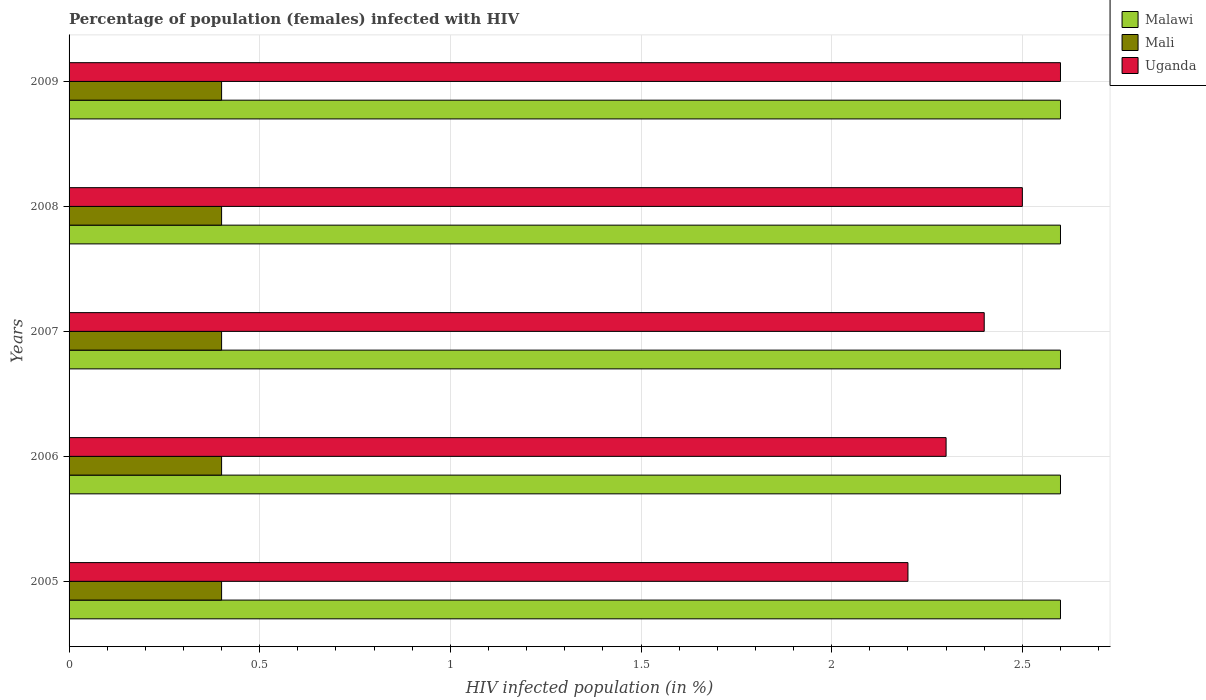How many groups of bars are there?
Keep it short and to the point. 5. In how many cases, is the number of bars for a given year not equal to the number of legend labels?
Offer a terse response. 0. What is the percentage of HIV infected female population in Mali in 2007?
Give a very brief answer. 0.4. Across all years, what is the maximum percentage of HIV infected female population in Uganda?
Your answer should be very brief. 2.6. In which year was the percentage of HIV infected female population in Mali maximum?
Your response must be concise. 2005. What is the total percentage of HIV infected female population in Mali in the graph?
Provide a short and direct response. 2. What is the difference between the percentage of HIV infected female population in Mali in 2007 and that in 2009?
Offer a terse response. 0. What is the difference between the percentage of HIV infected female population in Uganda in 2006 and the percentage of HIV infected female population in Malawi in 2009?
Provide a succinct answer. -0.3. In the year 2005, what is the difference between the percentage of HIV infected female population in Malawi and percentage of HIV infected female population in Uganda?
Your response must be concise. 0.4. Is the percentage of HIV infected female population in Malawi in 2006 less than that in 2007?
Make the answer very short. No. Is the difference between the percentage of HIV infected female population in Malawi in 2005 and 2009 greater than the difference between the percentage of HIV infected female population in Uganda in 2005 and 2009?
Make the answer very short. Yes. What is the difference between the highest and the lowest percentage of HIV infected female population in Malawi?
Your response must be concise. 0. Is the sum of the percentage of HIV infected female population in Malawi in 2005 and 2008 greater than the maximum percentage of HIV infected female population in Uganda across all years?
Ensure brevity in your answer.  Yes. What does the 3rd bar from the top in 2009 represents?
Provide a succinct answer. Malawi. What does the 2nd bar from the bottom in 2006 represents?
Ensure brevity in your answer.  Mali. Is it the case that in every year, the sum of the percentage of HIV infected female population in Mali and percentage of HIV infected female population in Uganda is greater than the percentage of HIV infected female population in Malawi?
Keep it short and to the point. No. How many bars are there?
Offer a terse response. 15. Are all the bars in the graph horizontal?
Give a very brief answer. Yes. How many years are there in the graph?
Your answer should be very brief. 5. Are the values on the major ticks of X-axis written in scientific E-notation?
Give a very brief answer. No. Does the graph contain any zero values?
Ensure brevity in your answer.  No. Does the graph contain grids?
Your answer should be compact. Yes. Where does the legend appear in the graph?
Ensure brevity in your answer.  Top right. How are the legend labels stacked?
Your response must be concise. Vertical. What is the title of the graph?
Offer a very short reply. Percentage of population (females) infected with HIV. What is the label or title of the X-axis?
Give a very brief answer. HIV infected population (in %). What is the HIV infected population (in %) in Mali in 2005?
Offer a terse response. 0.4. What is the HIV infected population (in %) in Uganda in 2005?
Your answer should be compact. 2.2. What is the HIV infected population (in %) in Malawi in 2006?
Offer a very short reply. 2.6. What is the HIV infected population (in %) of Mali in 2006?
Your response must be concise. 0.4. What is the HIV infected population (in %) of Malawi in 2007?
Your answer should be compact. 2.6. What is the HIV infected population (in %) of Mali in 2007?
Your answer should be compact. 0.4. What is the HIV infected population (in %) of Malawi in 2008?
Make the answer very short. 2.6. What is the HIV infected population (in %) of Mali in 2008?
Ensure brevity in your answer.  0.4. What is the HIV infected population (in %) in Mali in 2009?
Keep it short and to the point. 0.4. Across all years, what is the maximum HIV infected population (in %) in Uganda?
Your response must be concise. 2.6. What is the total HIV infected population (in %) in Malawi in the graph?
Provide a short and direct response. 13. What is the total HIV infected population (in %) in Mali in the graph?
Offer a terse response. 2. What is the difference between the HIV infected population (in %) of Malawi in 2005 and that in 2006?
Provide a succinct answer. 0. What is the difference between the HIV infected population (in %) in Mali in 2005 and that in 2006?
Your answer should be very brief. 0. What is the difference between the HIV infected population (in %) of Malawi in 2005 and that in 2007?
Ensure brevity in your answer.  0. What is the difference between the HIV infected population (in %) in Mali in 2005 and that in 2008?
Make the answer very short. 0. What is the difference between the HIV infected population (in %) of Uganda in 2005 and that in 2008?
Your answer should be compact. -0.3. What is the difference between the HIV infected population (in %) in Uganda in 2005 and that in 2009?
Provide a short and direct response. -0.4. What is the difference between the HIV infected population (in %) of Uganda in 2006 and that in 2007?
Provide a short and direct response. -0.1. What is the difference between the HIV infected population (in %) of Mali in 2006 and that in 2008?
Your response must be concise. 0. What is the difference between the HIV infected population (in %) in Uganda in 2006 and that in 2008?
Offer a very short reply. -0.2. What is the difference between the HIV infected population (in %) of Malawi in 2006 and that in 2009?
Ensure brevity in your answer.  0. What is the difference between the HIV infected population (in %) in Mali in 2006 and that in 2009?
Offer a terse response. 0. What is the difference between the HIV infected population (in %) of Mali in 2007 and that in 2008?
Your answer should be compact. 0. What is the difference between the HIV infected population (in %) in Malawi in 2007 and that in 2009?
Your response must be concise. 0. What is the difference between the HIV infected population (in %) in Mali in 2007 and that in 2009?
Provide a succinct answer. 0. What is the difference between the HIV infected population (in %) of Mali in 2008 and that in 2009?
Offer a terse response. 0. What is the difference between the HIV infected population (in %) of Malawi in 2005 and the HIV infected population (in %) of Mali in 2006?
Offer a very short reply. 2.2. What is the difference between the HIV infected population (in %) in Malawi in 2005 and the HIV infected population (in %) in Uganda in 2006?
Provide a short and direct response. 0.3. What is the difference between the HIV infected population (in %) in Mali in 2005 and the HIV infected population (in %) in Uganda in 2006?
Keep it short and to the point. -1.9. What is the difference between the HIV infected population (in %) in Malawi in 2005 and the HIV infected population (in %) in Uganda in 2007?
Your answer should be compact. 0.2. What is the difference between the HIV infected population (in %) in Malawi in 2005 and the HIV infected population (in %) in Mali in 2008?
Your answer should be compact. 2.2. What is the difference between the HIV infected population (in %) of Malawi in 2005 and the HIV infected population (in %) of Mali in 2009?
Your response must be concise. 2.2. What is the difference between the HIV infected population (in %) in Malawi in 2006 and the HIV infected population (in %) in Mali in 2007?
Offer a terse response. 2.2. What is the difference between the HIV infected population (in %) in Malawi in 2006 and the HIV infected population (in %) in Uganda in 2007?
Provide a succinct answer. 0.2. What is the difference between the HIV infected population (in %) in Mali in 2006 and the HIV infected population (in %) in Uganda in 2007?
Your response must be concise. -2. What is the difference between the HIV infected population (in %) of Malawi in 2006 and the HIV infected population (in %) of Uganda in 2008?
Provide a short and direct response. 0.1. What is the difference between the HIV infected population (in %) in Mali in 2006 and the HIV infected population (in %) in Uganda in 2008?
Provide a succinct answer. -2.1. What is the difference between the HIV infected population (in %) of Malawi in 2006 and the HIV infected population (in %) of Uganda in 2009?
Your answer should be very brief. 0. What is the difference between the HIV infected population (in %) of Mali in 2007 and the HIV infected population (in %) of Uganda in 2008?
Make the answer very short. -2.1. What is the difference between the HIV infected population (in %) of Malawi in 2007 and the HIV infected population (in %) of Mali in 2009?
Your response must be concise. 2.2. What is the difference between the HIV infected population (in %) of Malawi in 2007 and the HIV infected population (in %) of Uganda in 2009?
Your response must be concise. 0. What is the difference between the HIV infected population (in %) of Malawi in 2008 and the HIV infected population (in %) of Mali in 2009?
Ensure brevity in your answer.  2.2. What is the difference between the HIV infected population (in %) of Malawi in 2008 and the HIV infected population (in %) of Uganda in 2009?
Make the answer very short. 0. What is the difference between the HIV infected population (in %) of Mali in 2008 and the HIV infected population (in %) of Uganda in 2009?
Offer a terse response. -2.2. What is the average HIV infected population (in %) in Malawi per year?
Your answer should be very brief. 2.6. What is the average HIV infected population (in %) of Mali per year?
Provide a succinct answer. 0.4. In the year 2005, what is the difference between the HIV infected population (in %) of Malawi and HIV infected population (in %) of Uganda?
Offer a very short reply. 0.4. In the year 2005, what is the difference between the HIV infected population (in %) in Mali and HIV infected population (in %) in Uganda?
Provide a succinct answer. -1.8. In the year 2006, what is the difference between the HIV infected population (in %) of Malawi and HIV infected population (in %) of Uganda?
Provide a short and direct response. 0.3. In the year 2006, what is the difference between the HIV infected population (in %) of Mali and HIV infected population (in %) of Uganda?
Provide a short and direct response. -1.9. In the year 2007, what is the difference between the HIV infected population (in %) of Malawi and HIV infected population (in %) of Uganda?
Your response must be concise. 0.2. In the year 2007, what is the difference between the HIV infected population (in %) in Mali and HIV infected population (in %) in Uganda?
Offer a terse response. -2. In the year 2008, what is the difference between the HIV infected population (in %) of Malawi and HIV infected population (in %) of Mali?
Provide a succinct answer. 2.2. In the year 2009, what is the difference between the HIV infected population (in %) of Malawi and HIV infected population (in %) of Mali?
Make the answer very short. 2.2. What is the ratio of the HIV infected population (in %) of Uganda in 2005 to that in 2006?
Offer a terse response. 0.96. What is the ratio of the HIV infected population (in %) in Malawi in 2005 to that in 2008?
Your answer should be very brief. 1. What is the ratio of the HIV infected population (in %) of Mali in 2005 to that in 2008?
Ensure brevity in your answer.  1. What is the ratio of the HIV infected population (in %) of Uganda in 2005 to that in 2008?
Give a very brief answer. 0.88. What is the ratio of the HIV infected population (in %) of Malawi in 2005 to that in 2009?
Make the answer very short. 1. What is the ratio of the HIV infected population (in %) in Uganda in 2005 to that in 2009?
Ensure brevity in your answer.  0.85. What is the ratio of the HIV infected population (in %) of Malawi in 2006 to that in 2007?
Keep it short and to the point. 1. What is the ratio of the HIV infected population (in %) in Mali in 2006 to that in 2007?
Make the answer very short. 1. What is the ratio of the HIV infected population (in %) of Malawi in 2006 to that in 2008?
Ensure brevity in your answer.  1. What is the ratio of the HIV infected population (in %) in Mali in 2006 to that in 2008?
Keep it short and to the point. 1. What is the ratio of the HIV infected population (in %) in Uganda in 2006 to that in 2008?
Provide a succinct answer. 0.92. What is the ratio of the HIV infected population (in %) in Malawi in 2006 to that in 2009?
Provide a succinct answer. 1. What is the ratio of the HIV infected population (in %) in Mali in 2006 to that in 2009?
Offer a very short reply. 1. What is the ratio of the HIV infected population (in %) of Uganda in 2006 to that in 2009?
Provide a short and direct response. 0.88. What is the ratio of the HIV infected population (in %) in Mali in 2007 to that in 2008?
Keep it short and to the point. 1. What is the ratio of the HIV infected population (in %) of Malawi in 2007 to that in 2009?
Offer a terse response. 1. What is the ratio of the HIV infected population (in %) of Mali in 2007 to that in 2009?
Offer a terse response. 1. What is the ratio of the HIV infected population (in %) of Mali in 2008 to that in 2009?
Offer a very short reply. 1. What is the ratio of the HIV infected population (in %) in Uganda in 2008 to that in 2009?
Your answer should be very brief. 0.96. What is the difference between the highest and the second highest HIV infected population (in %) of Mali?
Give a very brief answer. 0. What is the difference between the highest and the lowest HIV infected population (in %) of Malawi?
Your response must be concise. 0. 